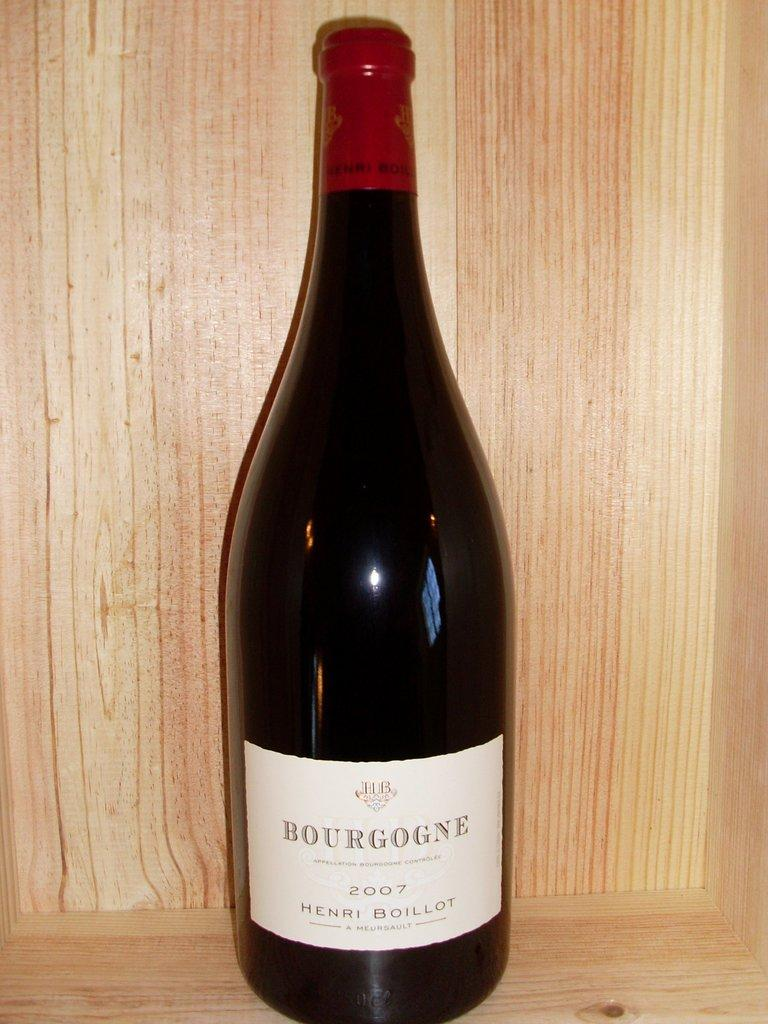<image>
Summarize the visual content of the image. Black alcohol bottle which says "Bourgogne" on it. 